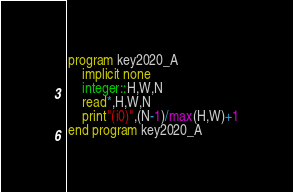Convert code to text. <code><loc_0><loc_0><loc_500><loc_500><_FORTRAN_>program key2020_A
    implicit none
    integer::H,W,N
    read*,H,W,N
    print"(i0)",(N-1)/max(H,W)+1
end program key2020_A</code> 